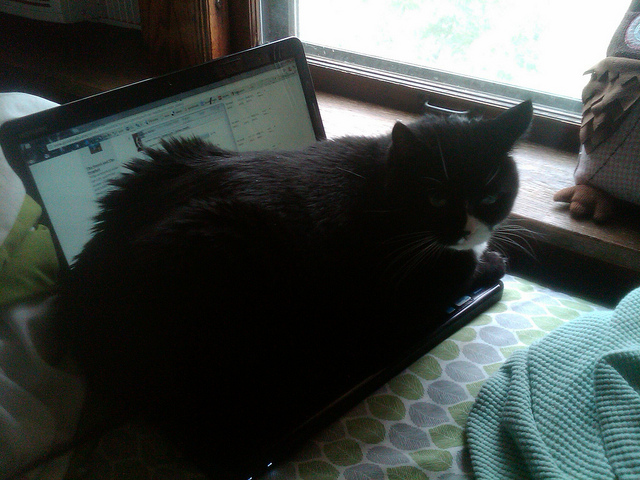<image>What species of cats is looking outside the window? It is unknown what species of cat is looking outside the window. What species of cats is looking outside the window? It is ambiguous what species of cat is looking outside the window. It can be seen as 'long hair', 'tuxedo', 'black', 'domestic shorthair' or 'domestic'. 